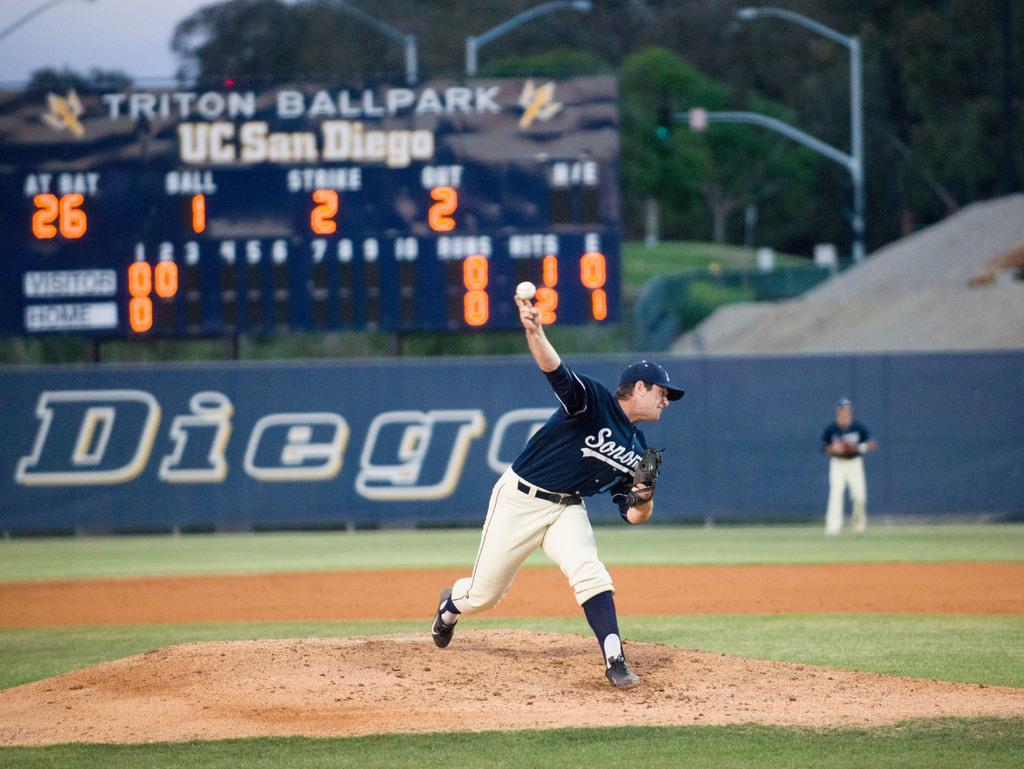<image>
Describe the image concisely. The sign at Triton Ballpark says that there has been 1 ball so far. 